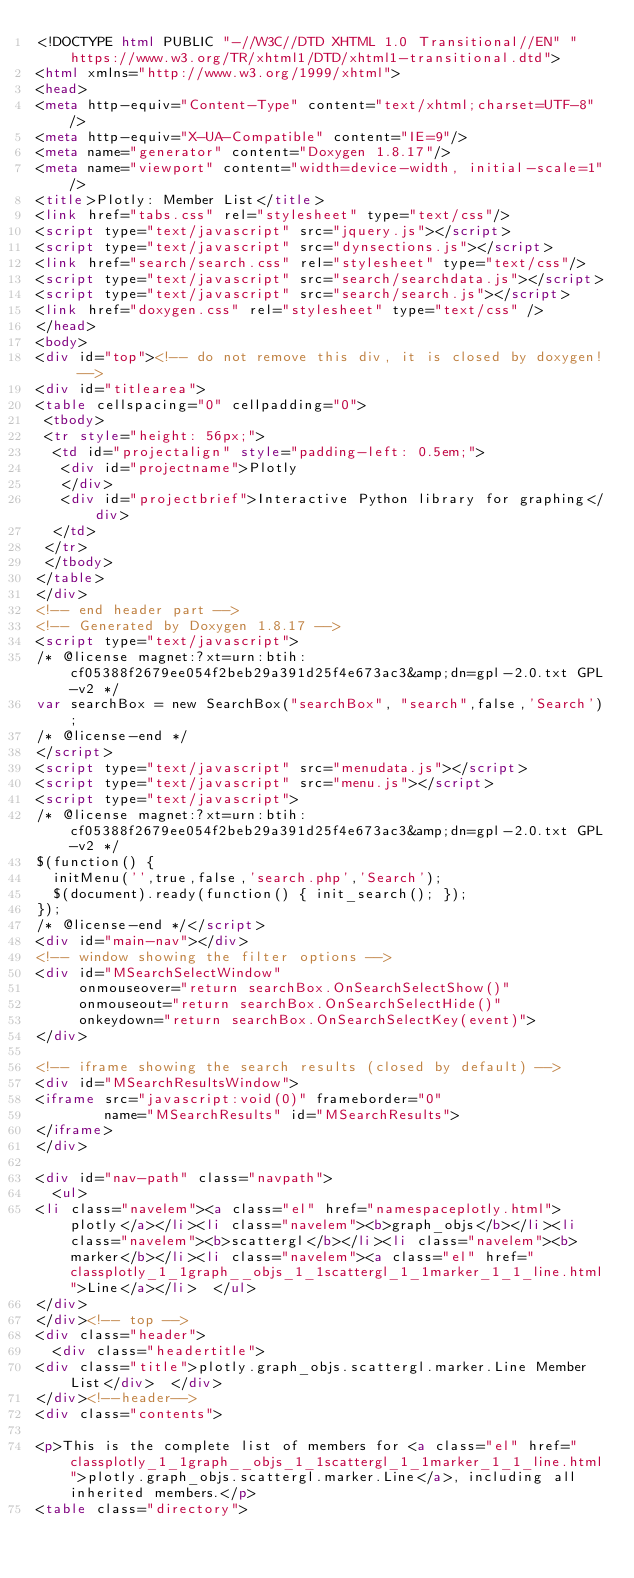<code> <loc_0><loc_0><loc_500><loc_500><_HTML_><!DOCTYPE html PUBLIC "-//W3C//DTD XHTML 1.0 Transitional//EN" "https://www.w3.org/TR/xhtml1/DTD/xhtml1-transitional.dtd">
<html xmlns="http://www.w3.org/1999/xhtml">
<head>
<meta http-equiv="Content-Type" content="text/xhtml;charset=UTF-8"/>
<meta http-equiv="X-UA-Compatible" content="IE=9"/>
<meta name="generator" content="Doxygen 1.8.17"/>
<meta name="viewport" content="width=device-width, initial-scale=1"/>
<title>Plotly: Member List</title>
<link href="tabs.css" rel="stylesheet" type="text/css"/>
<script type="text/javascript" src="jquery.js"></script>
<script type="text/javascript" src="dynsections.js"></script>
<link href="search/search.css" rel="stylesheet" type="text/css"/>
<script type="text/javascript" src="search/searchdata.js"></script>
<script type="text/javascript" src="search/search.js"></script>
<link href="doxygen.css" rel="stylesheet" type="text/css" />
</head>
<body>
<div id="top"><!-- do not remove this div, it is closed by doxygen! -->
<div id="titlearea">
<table cellspacing="0" cellpadding="0">
 <tbody>
 <tr style="height: 56px;">
  <td id="projectalign" style="padding-left: 0.5em;">
   <div id="projectname">Plotly
   </div>
   <div id="projectbrief">Interactive Python library for graphing</div>
  </td>
 </tr>
 </tbody>
</table>
</div>
<!-- end header part -->
<!-- Generated by Doxygen 1.8.17 -->
<script type="text/javascript">
/* @license magnet:?xt=urn:btih:cf05388f2679ee054f2beb29a391d25f4e673ac3&amp;dn=gpl-2.0.txt GPL-v2 */
var searchBox = new SearchBox("searchBox", "search",false,'Search');
/* @license-end */
</script>
<script type="text/javascript" src="menudata.js"></script>
<script type="text/javascript" src="menu.js"></script>
<script type="text/javascript">
/* @license magnet:?xt=urn:btih:cf05388f2679ee054f2beb29a391d25f4e673ac3&amp;dn=gpl-2.0.txt GPL-v2 */
$(function() {
  initMenu('',true,false,'search.php','Search');
  $(document).ready(function() { init_search(); });
});
/* @license-end */</script>
<div id="main-nav"></div>
<!-- window showing the filter options -->
<div id="MSearchSelectWindow"
     onmouseover="return searchBox.OnSearchSelectShow()"
     onmouseout="return searchBox.OnSearchSelectHide()"
     onkeydown="return searchBox.OnSearchSelectKey(event)">
</div>

<!-- iframe showing the search results (closed by default) -->
<div id="MSearchResultsWindow">
<iframe src="javascript:void(0)" frameborder="0" 
        name="MSearchResults" id="MSearchResults">
</iframe>
</div>

<div id="nav-path" class="navpath">
  <ul>
<li class="navelem"><a class="el" href="namespaceplotly.html">plotly</a></li><li class="navelem"><b>graph_objs</b></li><li class="navelem"><b>scattergl</b></li><li class="navelem"><b>marker</b></li><li class="navelem"><a class="el" href="classplotly_1_1graph__objs_1_1scattergl_1_1marker_1_1_line.html">Line</a></li>  </ul>
</div>
</div><!-- top -->
<div class="header">
  <div class="headertitle">
<div class="title">plotly.graph_objs.scattergl.marker.Line Member List</div>  </div>
</div><!--header-->
<div class="contents">

<p>This is the complete list of members for <a class="el" href="classplotly_1_1graph__objs_1_1scattergl_1_1marker_1_1_line.html">plotly.graph_objs.scattergl.marker.Line</a>, including all inherited members.</p>
<table class="directory"></code> 